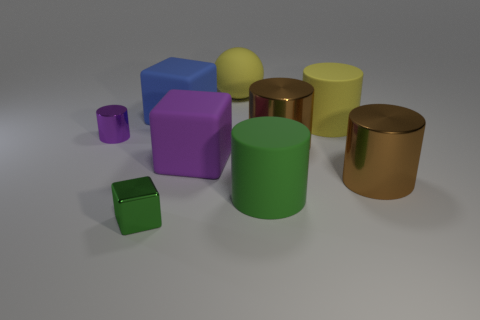What can you infer about the lighting in the scene? The lighting in the image suggests a single diffuse light source, probably overhead, given the soft shadows cast by the objects on the surface. There's no harsh light or strong directional shadows, which indicates the light source is not extremely close or pointed directly at any of the objects. 